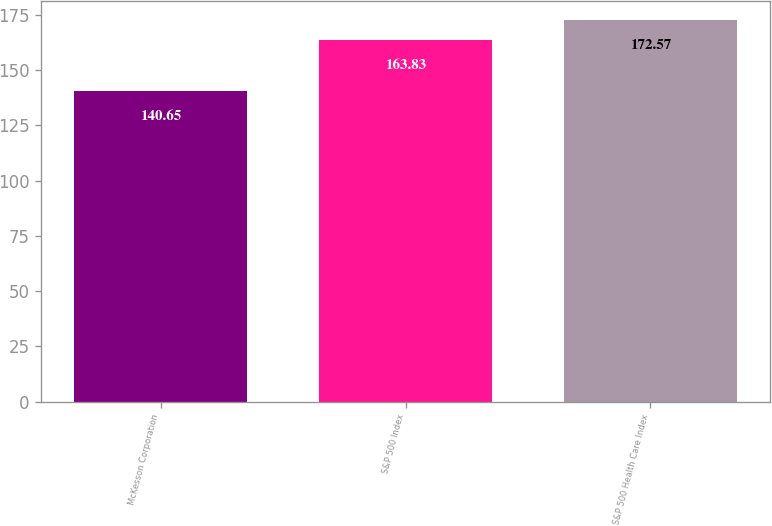Convert chart to OTSL. <chart><loc_0><loc_0><loc_500><loc_500><bar_chart><fcel>McKesson Corporation<fcel>S&P 500 Index<fcel>S&P 500 Health Care Index<nl><fcel>140.65<fcel>163.83<fcel>172.57<nl></chart> 